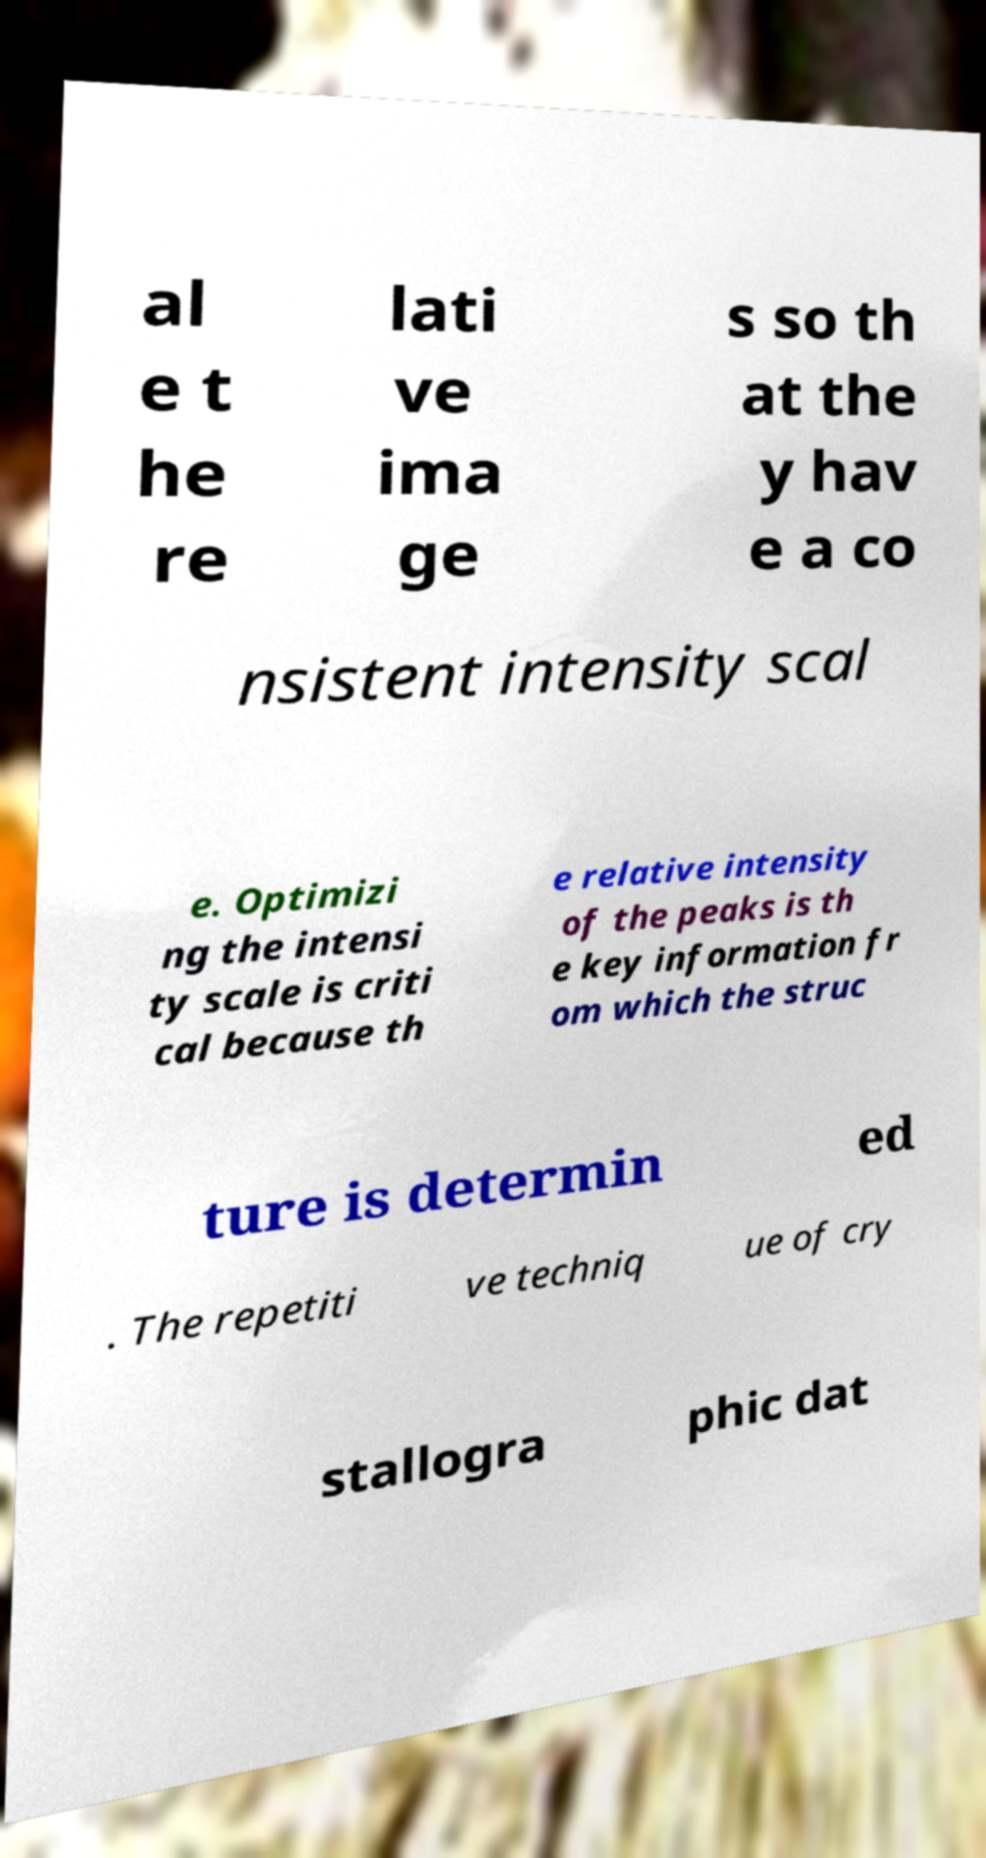What messages or text are displayed in this image? I need them in a readable, typed format. al e t he re lati ve ima ge s so th at the y hav e a co nsistent intensity scal e. Optimizi ng the intensi ty scale is criti cal because th e relative intensity of the peaks is th e key information fr om which the struc ture is determin ed . The repetiti ve techniq ue of cry stallogra phic dat 